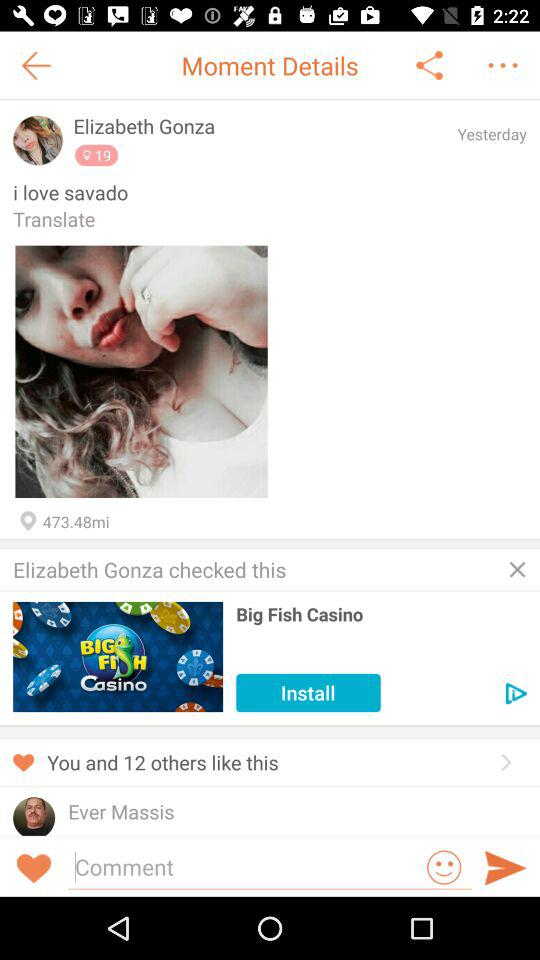How many people like this moment?
Answer the question using a single word or phrase. 13 